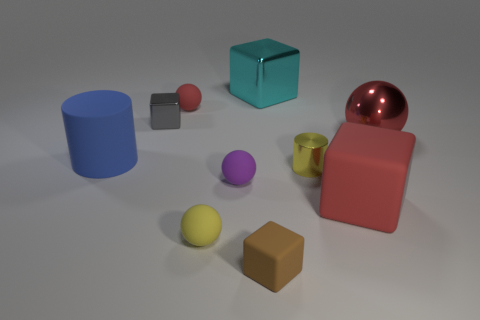There is a yellow shiny thing that is the same size as the yellow rubber ball; what shape is it?
Offer a terse response. Cylinder. Does the yellow cylinder in front of the red shiny sphere have the same material as the red sphere in front of the gray cube?
Offer a very short reply. Yes. The big cube in front of the big metal thing that is behind the red metallic object is made of what material?
Offer a very short reply. Rubber. There is a metallic object on the left side of the tiny thing that is behind the tiny shiny thing that is behind the large blue rubber thing; what is its size?
Offer a very short reply. Small. Does the metallic cylinder have the same size as the brown matte block?
Make the answer very short. Yes. Does the big metal thing that is in front of the small red sphere have the same shape as the yellow thing to the left of the brown rubber thing?
Give a very brief answer. Yes. There is a big metal thing right of the tiny yellow metal object; are there any big metal balls in front of it?
Provide a succinct answer. No. Is there a big brown rubber cylinder?
Give a very brief answer. No. How many cylinders have the same size as the gray shiny thing?
Your answer should be compact. 1. How many yellow objects are both to the right of the large cyan object and in front of the purple matte object?
Offer a very short reply. 0. 